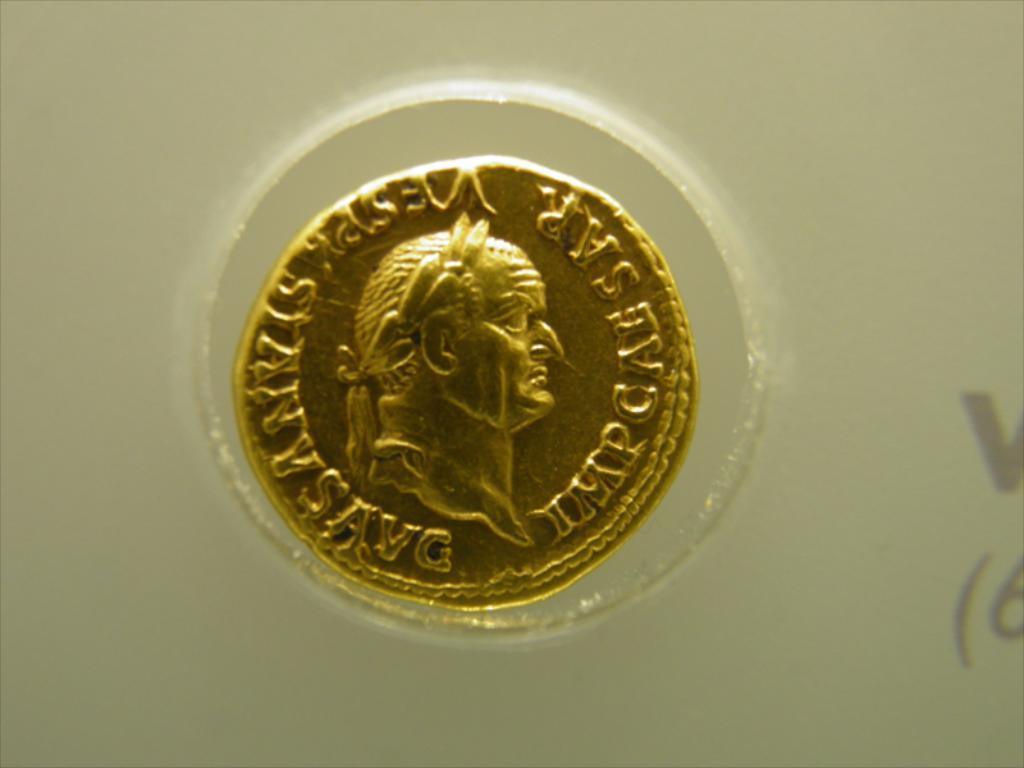<image>
Present a compact description of the photo's key features. a gold coin on display with a person's profile and words SAR 